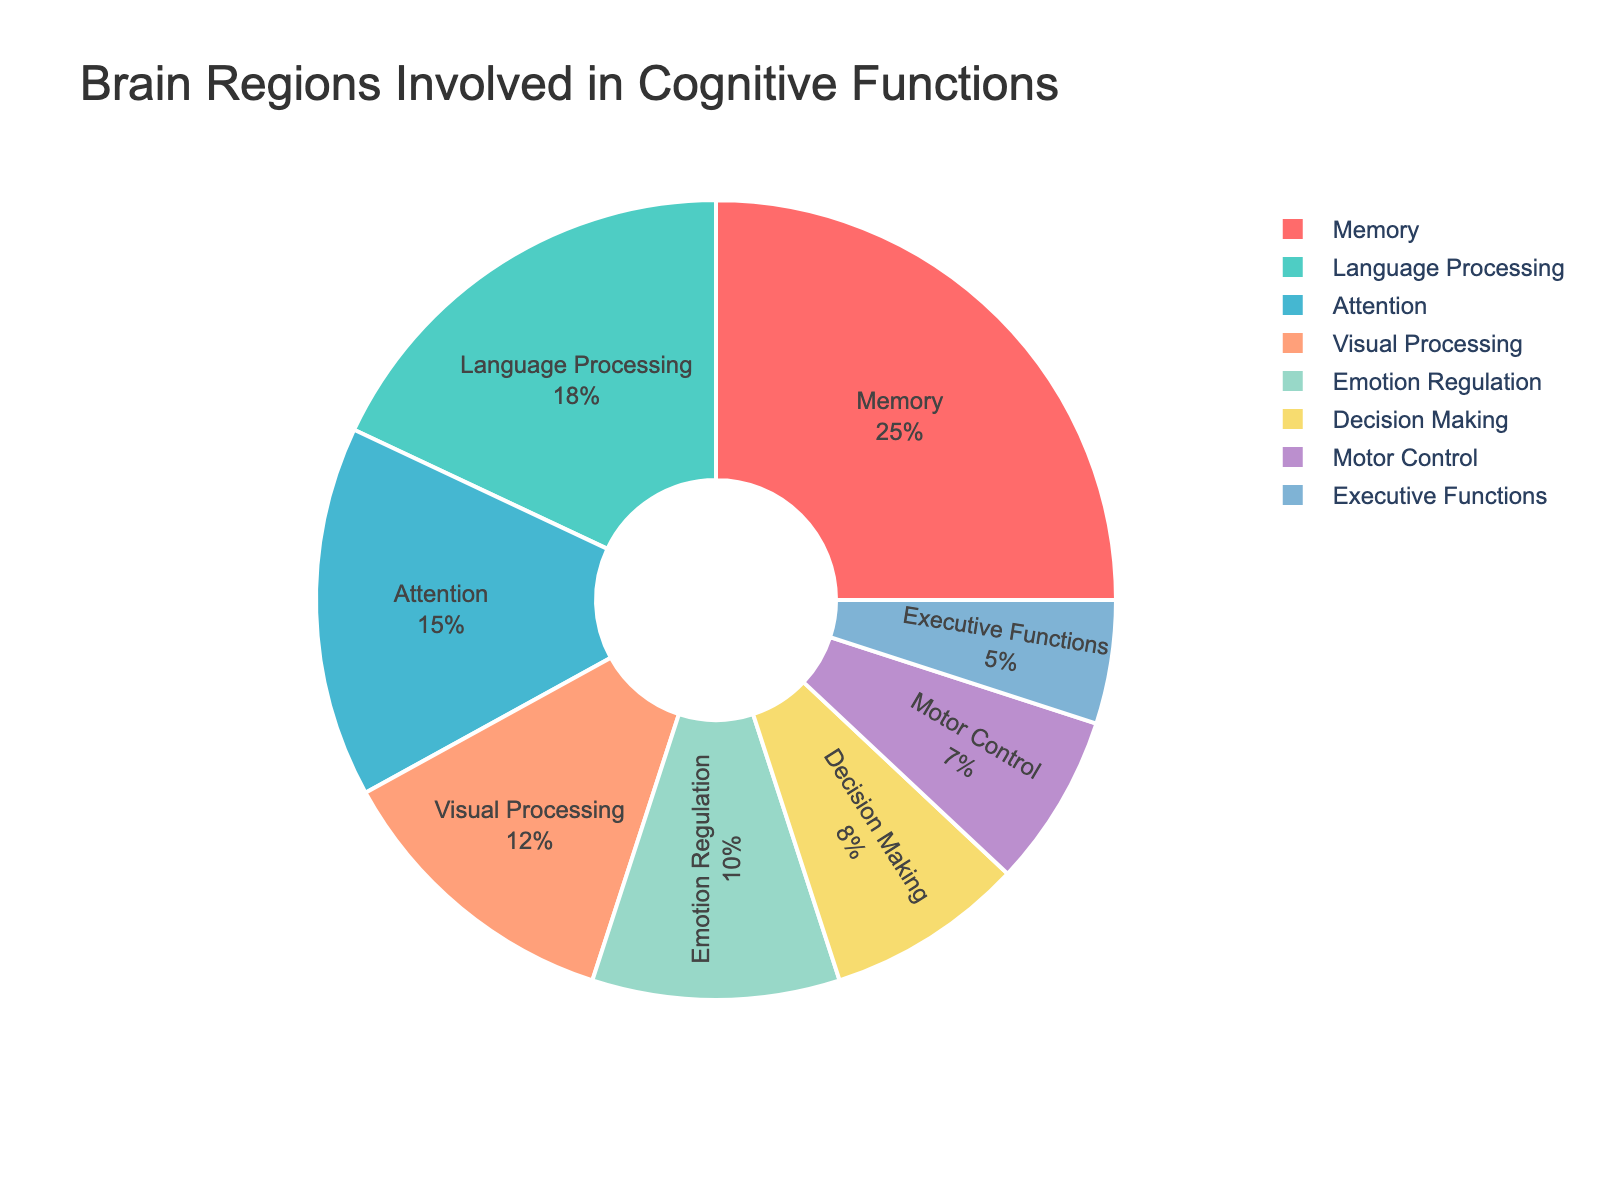Which cognitive function has the highest percentage involvement according to the pie chart? The largest slice on the pie chart represents the cognitive function with the highest involvement. By examining the chart, we can see which labeled slice occupies the most space.
Answer: Memory Which cognitive function has the smallest percentage involvement in the brain regions? The smallest slice on the pie chart represents the cognitive function with the least involvement. By checking the smallest labeled slice's size, we identify the cognitive function.
Answer: Executive Functions How many cognitive functions together make up more than half of the total brain regions' involvement? To determine this, we add the percentages of the largest slices step-by-step until their cumulative total exceeds 50%. According to the chart, Memory (25) and Language Processing (18) sum to 43, and adding Attention (15) results in 58, which is over half.
Answer: 3 Is the percentage involvement of Language Processing greater than Visual Processing? By comparing the sizes labeled on the pie chart, we check if the percentage for Language Processing (18) is greater than that for Visual Processing (12).
Answer: Yes What is the combined percentage of Emotion Regulation, Decision Making, and Motor Control? Adding the percentages of these functions: Emotion Regulation (10), Decision Making (8), and Motor Control (7), sum up to 10 + 8 + 7.
Answer: 25 Which color represents Memory in the pie chart? Observing the chart and matching the color to the legend or label near the Memory slice helps us identify the color.
Answer: Red By what percentage does Attention differ from Executive Functions? We calculate the difference by subtracting the percentage of Executive Functions (5) from that of Attention (15).
Answer: 10 What is the total percentage of functions involved in decision processes (Decision Making and Executive Functions)? Adding the percentages of Decision Making (8) and Executive Functions (5) provides the total.
Answer: 13 